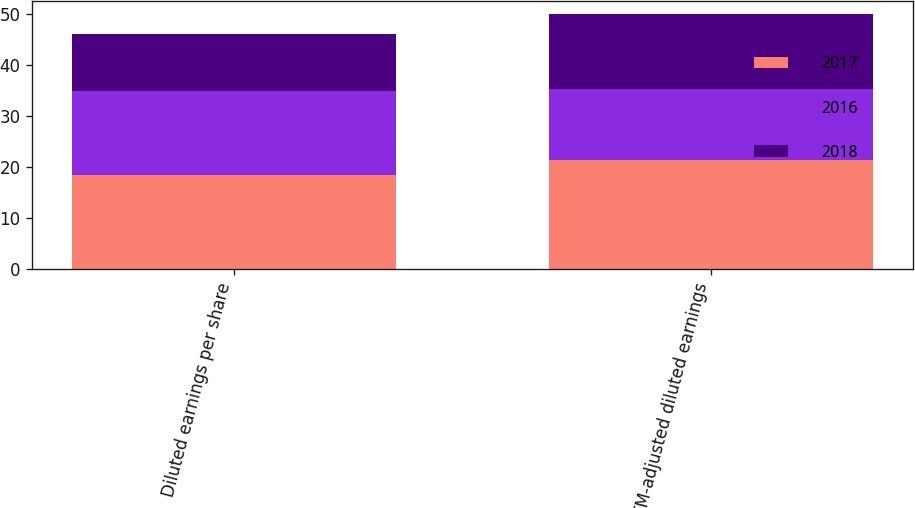<chart> <loc_0><loc_0><loc_500><loc_500><stacked_bar_chart><ecel><fcel>Diluted earnings per share<fcel>MTM-adjusted diluted earnings<nl><fcel>2017<fcel>18.49<fcel>21.33<nl><fcel>2016<fcel>16.34<fcel>14.04<nl><fcel>2018<fcel>11.32<fcel>14.59<nl></chart> 